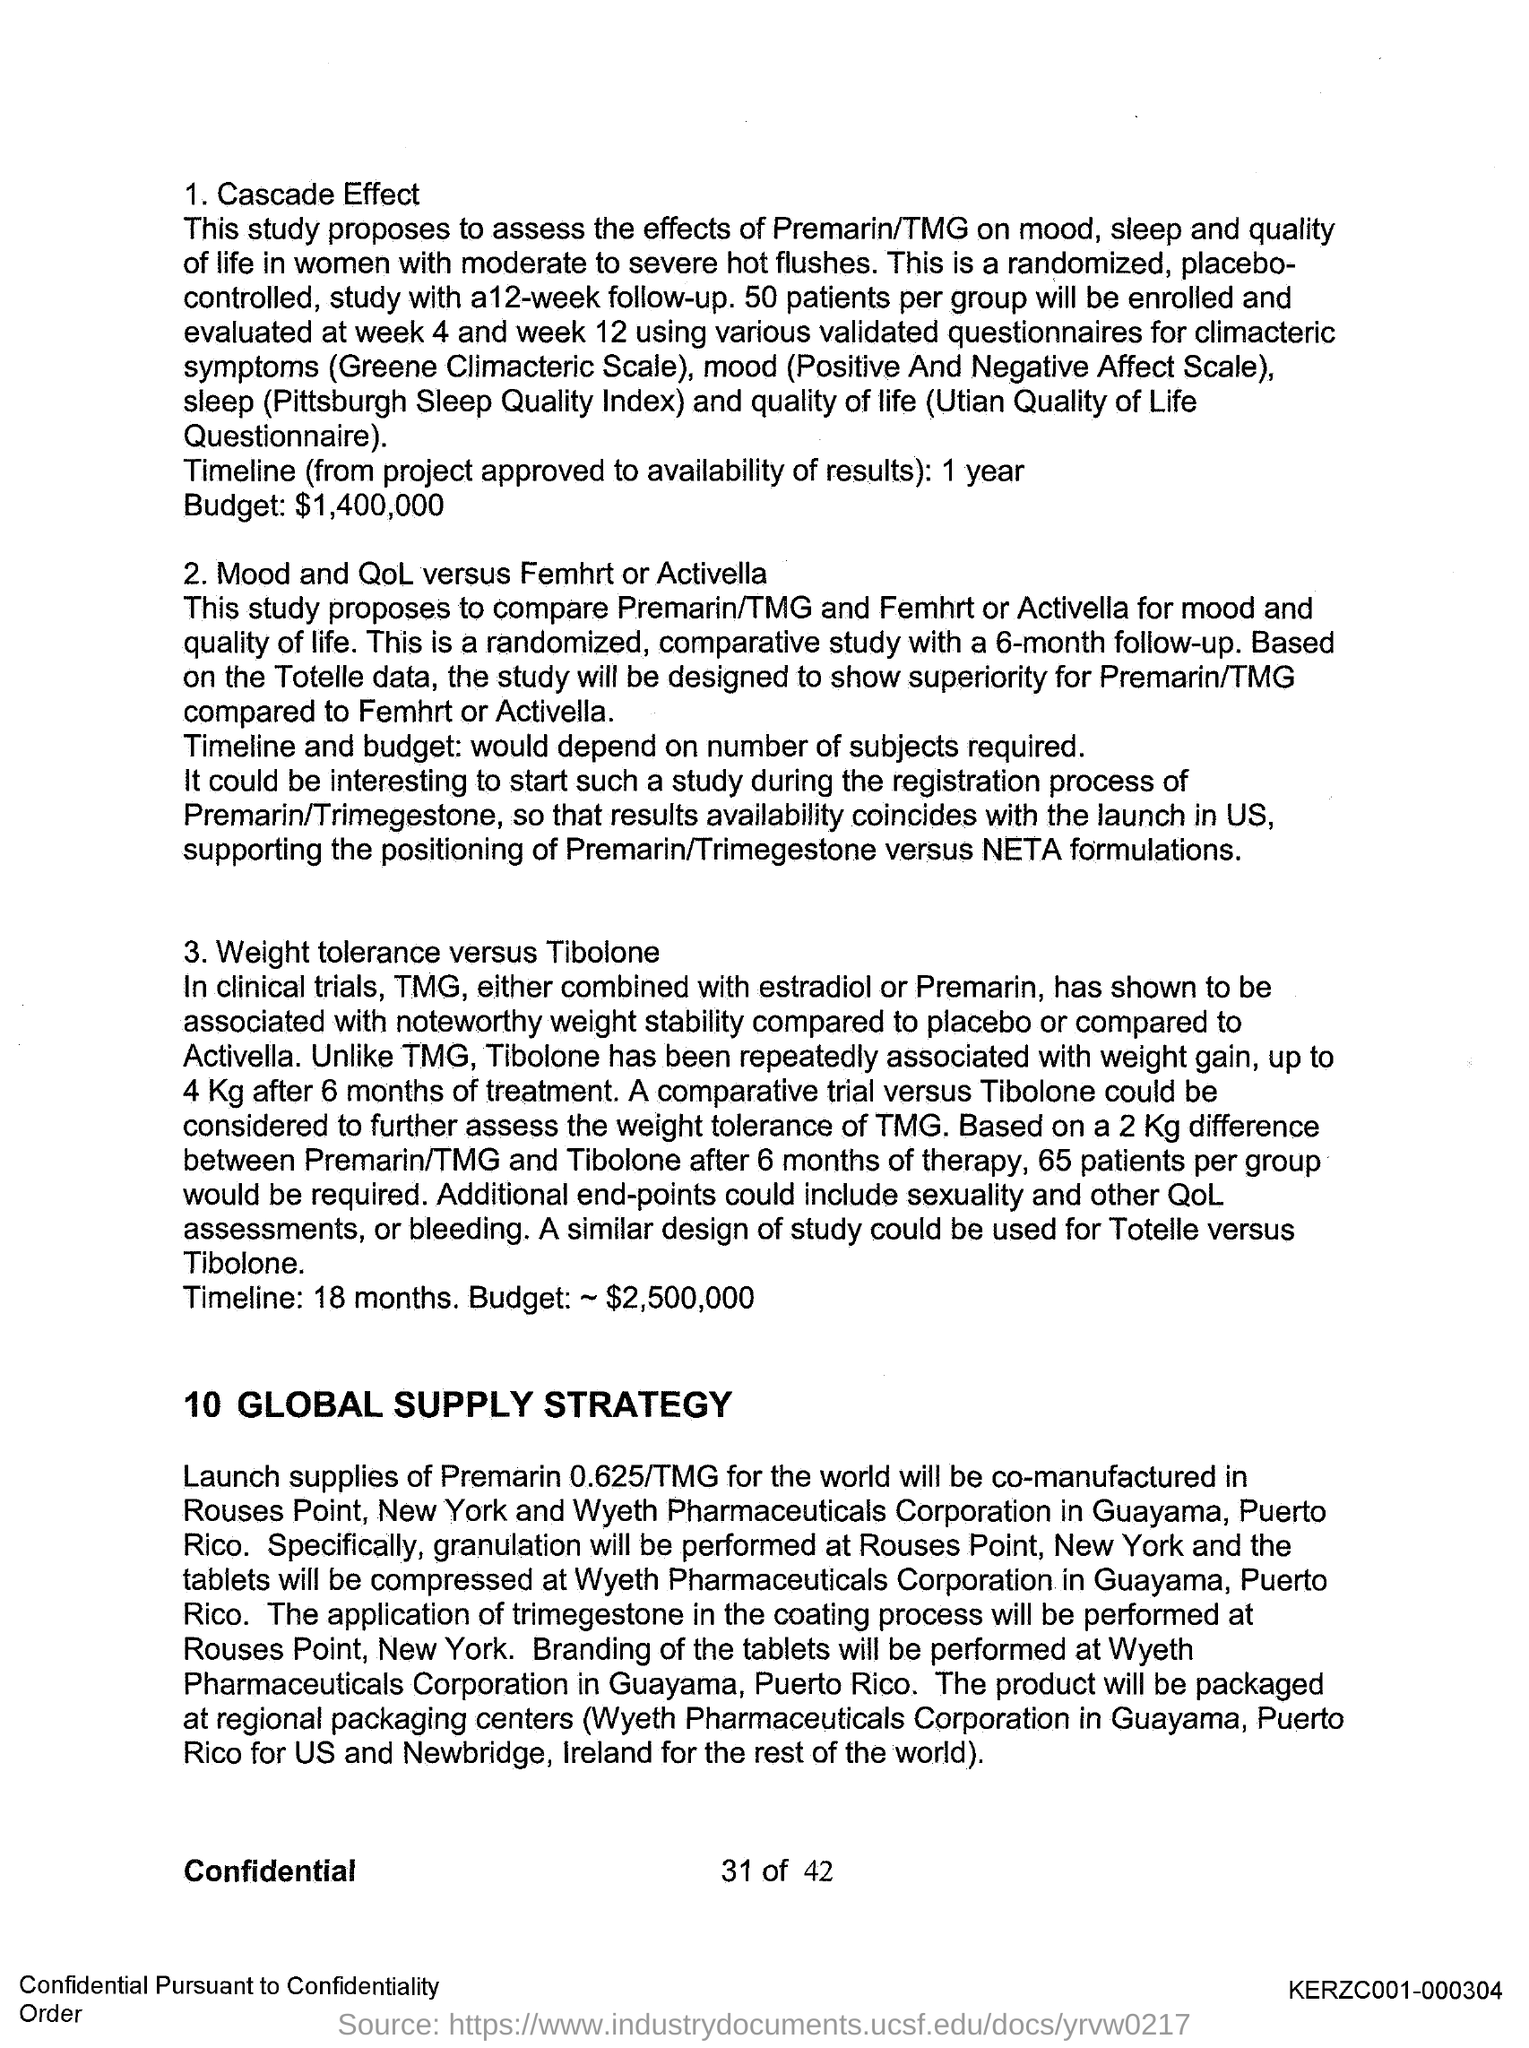List a handful of essential elements in this visual. The timeline of the cascade effect is expected to span over a period of one year. The timeline for weight tolerance and tibolone is 18 months. The budget for the weight tolerance versus tibolone study is $2,500,000. The total budget for the cascade effect is $1,400,000. 